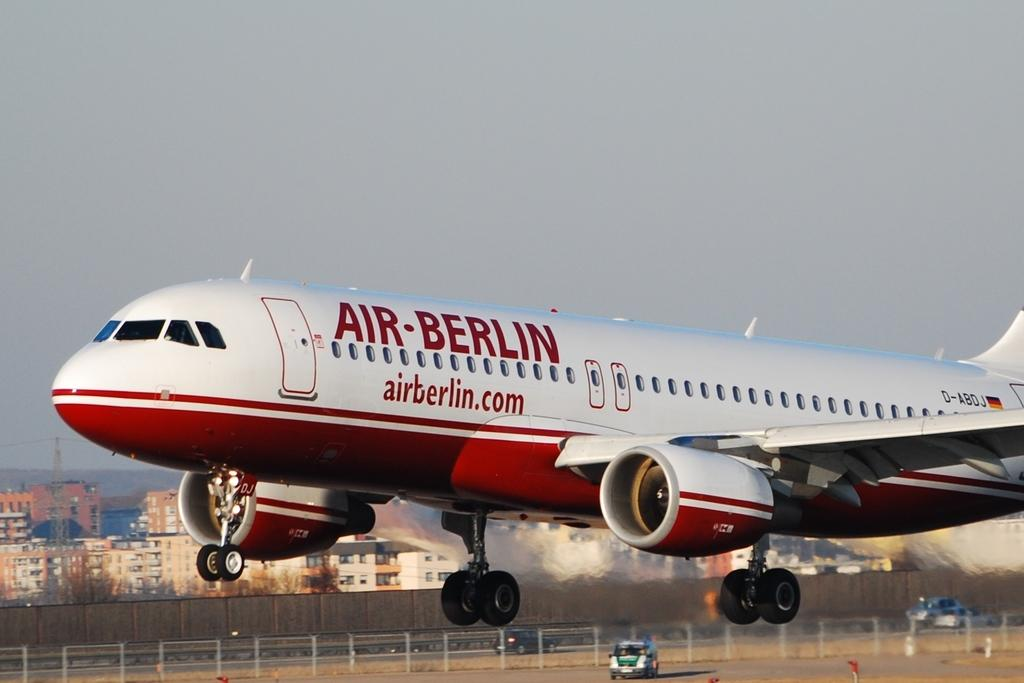Provide a one-sentence caption for the provided image. a red and white airplane with the air berlin logo on its side. 